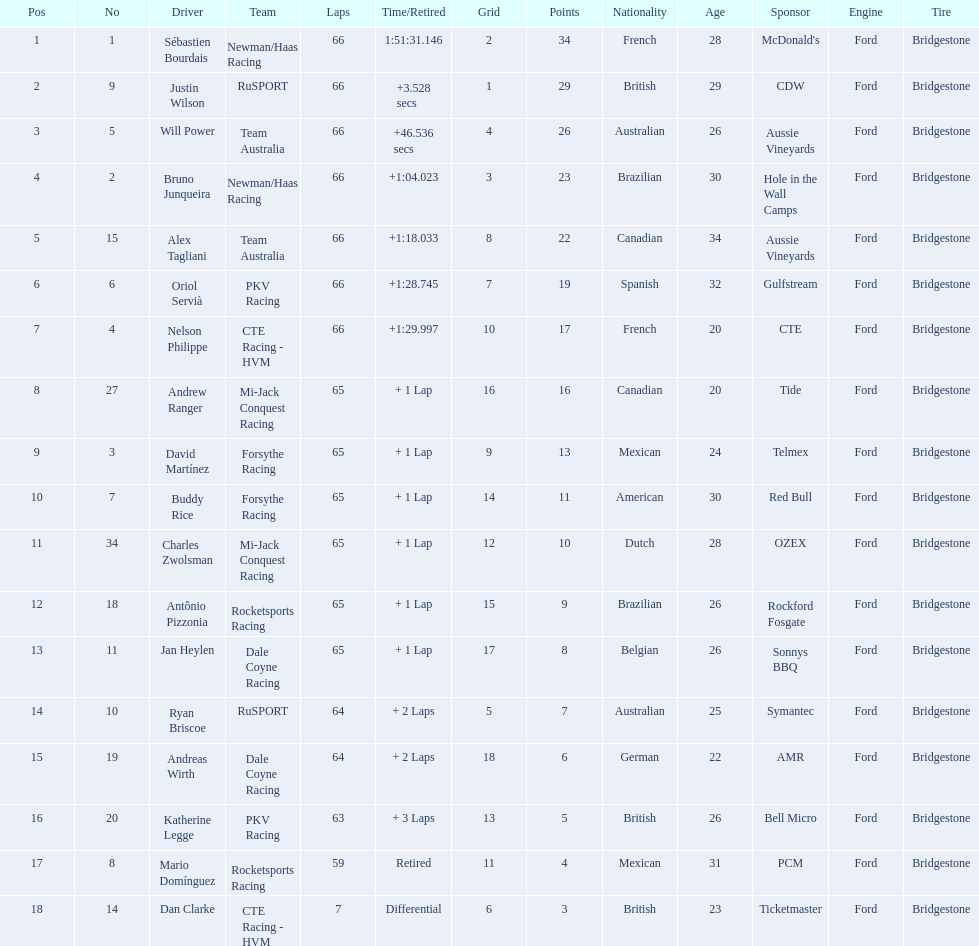What are the names of the drivers who were in position 14 through position 18? Ryan Briscoe, Andreas Wirth, Katherine Legge, Mario Domínguez, Dan Clarke. Of these , which ones didn't finish due to retired or differential? Mario Domínguez, Dan Clarke. Which one of the previous drivers retired? Mario Domínguez. Which of the drivers in question 2 had a differential? Dan Clarke. 